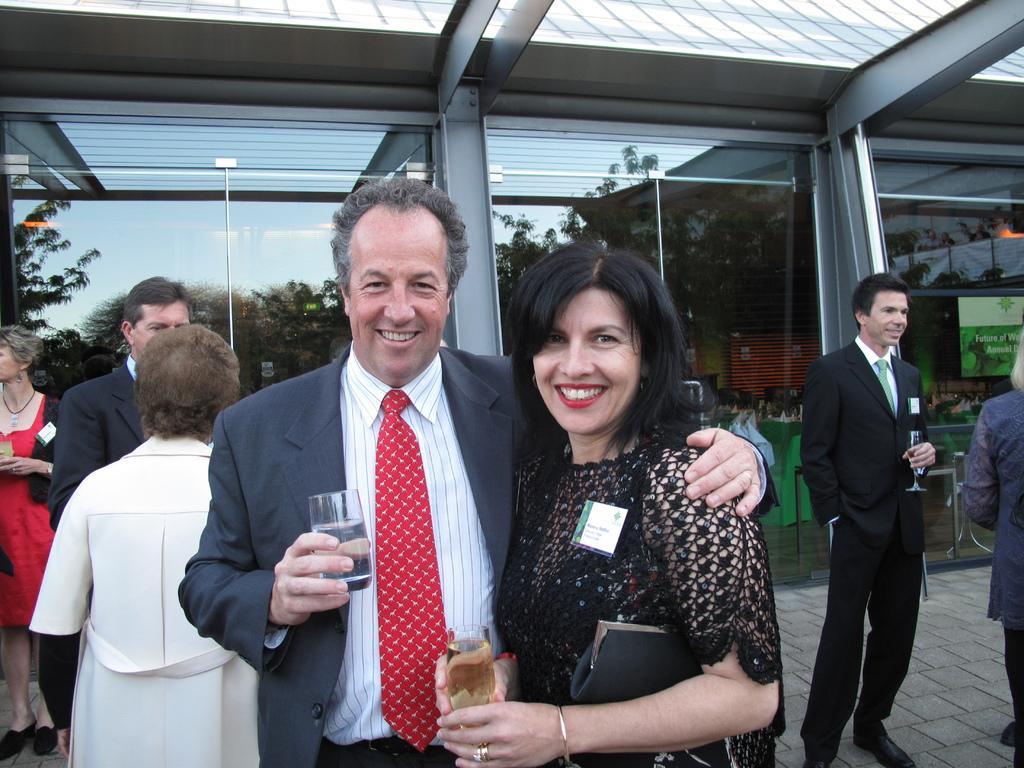How would you summarize this image in a sentence or two? In this image we can see the people standing on the ground and holding glasses. In the background, we can see the windows and board with text attached to the window. And we can see the reflection of trees on the window. 